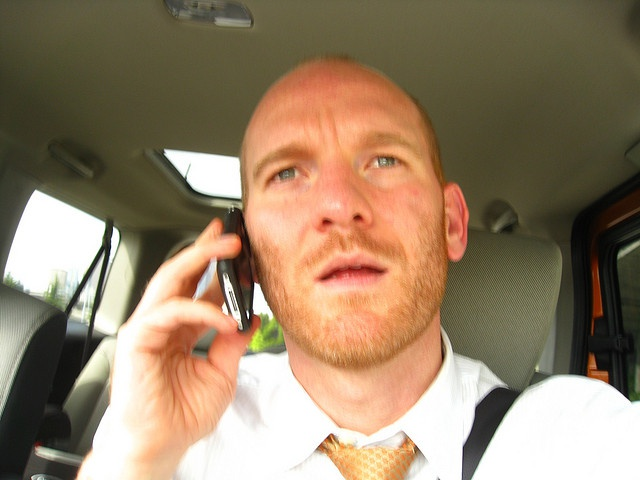Describe the objects in this image and their specific colors. I can see people in darkgreen, white, and tan tones, tie in darkgreen, tan, and khaki tones, and cell phone in darkgreen, black, maroon, white, and gray tones in this image. 